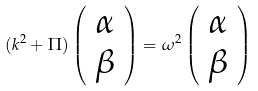<formula> <loc_0><loc_0><loc_500><loc_500>( k ^ { 2 } + \Pi ) \left ( \begin{array} { c c } \alpha \\ \beta \end{array} \right ) = \omega ^ { 2 } \left ( \begin{array} { c c } \alpha \\ \beta \end{array} \right )</formula> 